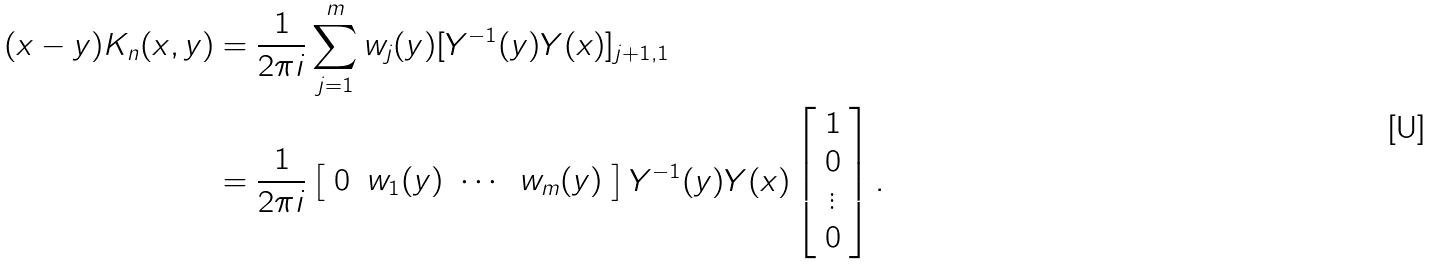<formula> <loc_0><loc_0><loc_500><loc_500>( x - y ) K _ { n } ( x , y ) & = \frac { 1 } { 2 \pi i } \sum _ { j = 1 } ^ { m } w _ { j } ( y ) [ Y ^ { - 1 } ( y ) Y ( x ) ] _ { j + 1 , 1 } \\ & = \frac { 1 } { 2 \pi i } \left [ \begin{array} { c c c c } 0 & w _ { 1 } ( y ) & \cdots & w _ { m } ( y ) \end{array} \right ] Y ^ { - 1 } ( y ) Y ( x ) \left [ \begin{array} { c } 1 \\ 0 \\ \vdots \\ 0 \end{array} \right ] .</formula> 